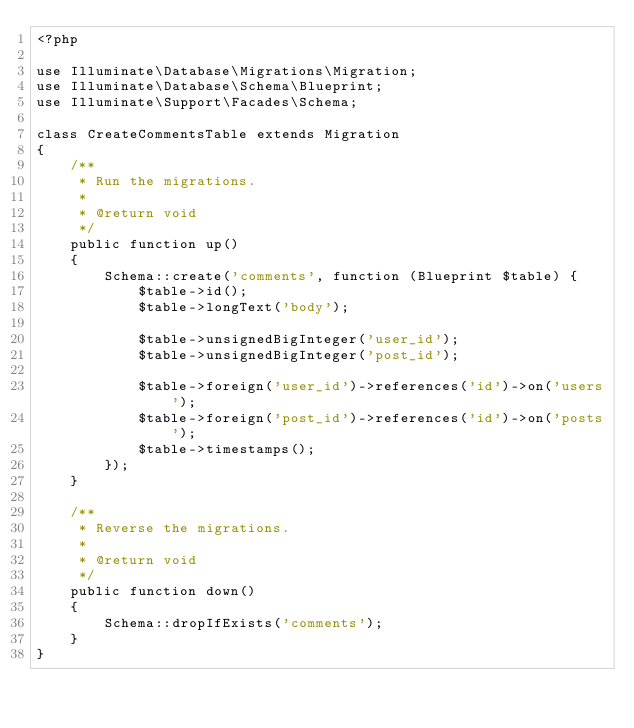<code> <loc_0><loc_0><loc_500><loc_500><_PHP_><?php

use Illuminate\Database\Migrations\Migration;
use Illuminate\Database\Schema\Blueprint;
use Illuminate\Support\Facades\Schema;

class CreateCommentsTable extends Migration
{
    /**
     * Run the migrations.
     *
     * @return void
     */
    public function up()
    {
        Schema::create('comments', function (Blueprint $table) {
            $table->id();
            $table->longText('body');
            
            $table->unsignedBigInteger('user_id');
            $table->unsignedBigInteger('post_id');
            
            $table->foreign('user_id')->references('id')->on('users');
            $table->foreign('post_id')->references('id')->on('posts');
            $table->timestamps();
        });
    }

    /**
     * Reverse the migrations.
     *
     * @return void
     */
    public function down()
    {
        Schema::dropIfExists('comments');
    }
}
</code> 